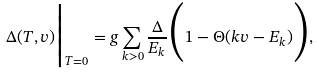Convert formula to latex. <formula><loc_0><loc_0><loc_500><loc_500>\Delta ( T , v ) \Big | _ { T = 0 } = g \sum _ { k > 0 } \frac { \Delta } { E _ { k } } \Big ( 1 - \Theta ( k v - E _ { k } ) \Big ) ,</formula> 